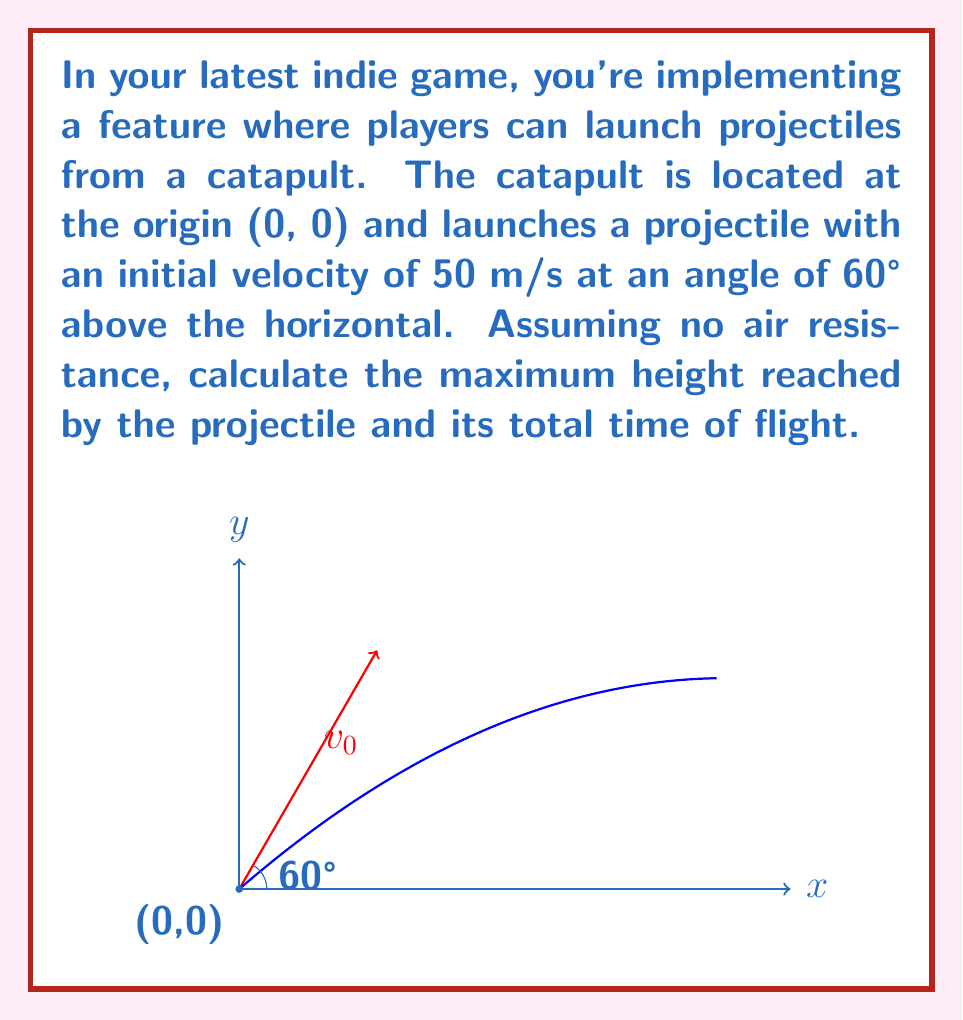Give your solution to this math problem. Let's approach this problem step-by-step using vector components:

1) First, let's break down the initial velocity into its x and y components:

   $v_{0x} = v_0 \cos \theta = 50 \cos 60° = 25$ m/s
   $v_{0y} = v_0 \sin \theta = 50 \sin 60° = 43.3$ m/s

2) The time to reach maximum height is when the y-component of velocity becomes zero:

   $v_y = v_{0y} - gt = 0$
   $t = \frac{v_{0y}}{g} = \frac{43.3}{9.8} = 4.42$ s

3) The maximum height can be calculated using the equation:

   $y = v_{0y}t - \frac{1}{2}gt^2$

   Substituting $t = 4.42$ s:

   $y_{max} = 43.3 * 4.42 - \frac{1}{2} * 9.8 * 4.42^2 = 95.7$ m

4) The total time of flight is twice the time to reach maximum height:

   $t_{total} = 2 * 4.42 = 8.84$ s

Therefore, the maximum height reached is 95.7 m and the total time of flight is 8.84 s.
Answer: Maximum height: 95.7 m; Total flight time: 8.84 s 